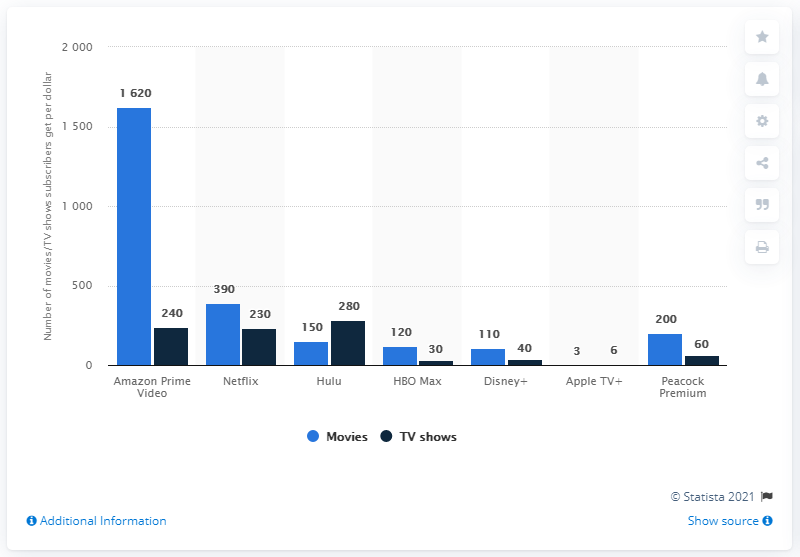Identify some key points in this picture. Hulu was the most valuable service for subscribers interested in TV shows. In the United States, as of December 2020, Amazon Prime Video was considered the most valuable service. HBO Max, a recently launched service, has more content than Disney+ and Apple TV+. 